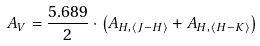Convert formula to latex. <formula><loc_0><loc_0><loc_500><loc_500>A _ { V } = \frac { 5 . 6 8 9 } { 2 } \cdot \left ( A _ { H , \left < J - H \right > } + A _ { H , \left < H - K \right > } \right )</formula> 